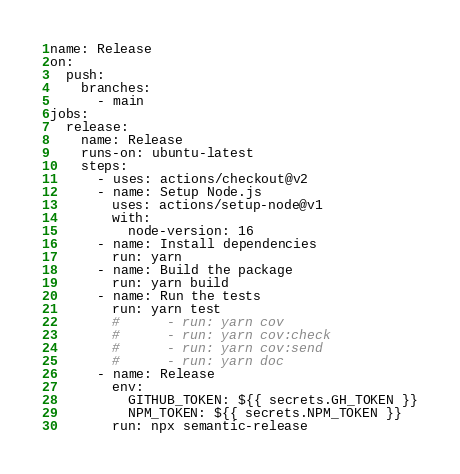Convert code to text. <code><loc_0><loc_0><loc_500><loc_500><_YAML_>name: Release
on:
  push:
    branches:
      - main
jobs:
  release:
    name: Release
    runs-on: ubuntu-latest
    steps:
      - uses: actions/checkout@v2
      - name: Setup Node.js
        uses: actions/setup-node@v1
        with:
          node-version: 16
      - name: Install dependencies
        run: yarn
      - name: Build the package
        run: yarn build
      - name: Run the tests
        run: yarn test
        #      - run: yarn cov
        #      - run: yarn cov:check
        #      - run: yarn cov:send
        #      - run: yarn doc
      - name: Release
        env:
          GITHUB_TOKEN: ${{ secrets.GH_TOKEN }}
          NPM_TOKEN: ${{ secrets.NPM_TOKEN }}
        run: npx semantic-release
</code> 